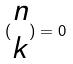Convert formula to latex. <formula><loc_0><loc_0><loc_500><loc_500>( \begin{matrix} n \\ k \end{matrix} ) = 0</formula> 